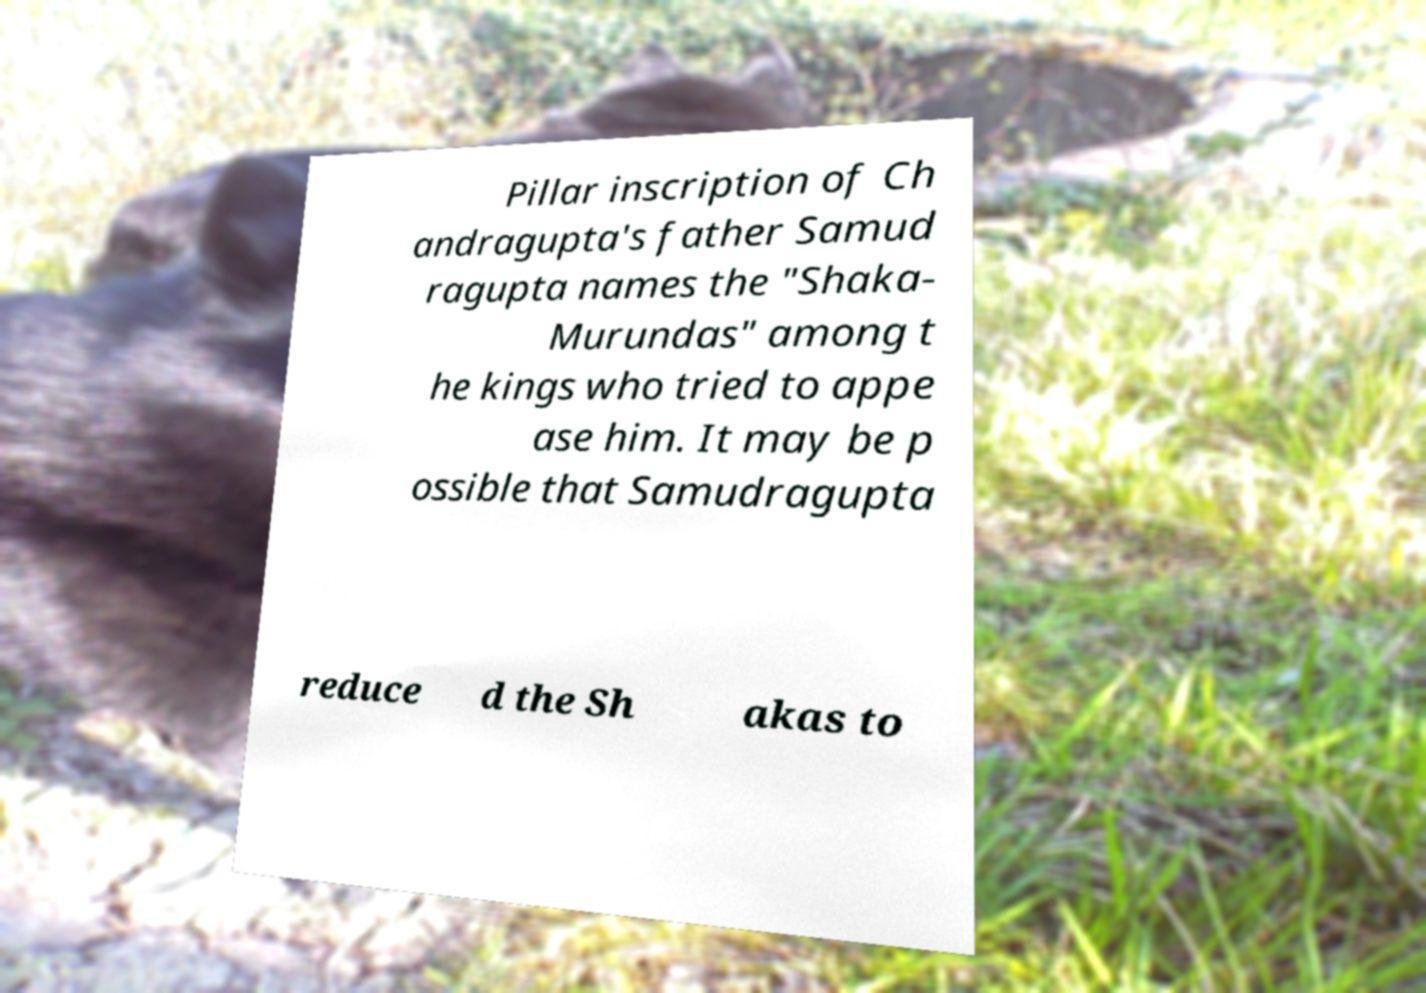What messages or text are displayed in this image? I need them in a readable, typed format. Pillar inscription of Ch andragupta's father Samud ragupta names the "Shaka- Murundas" among t he kings who tried to appe ase him. It may be p ossible that Samudragupta reduce d the Sh akas to 